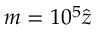Convert formula to latex. <formula><loc_0><loc_0><loc_500><loc_500>m = 1 0 ^ { 5 } \hat { z }</formula> 